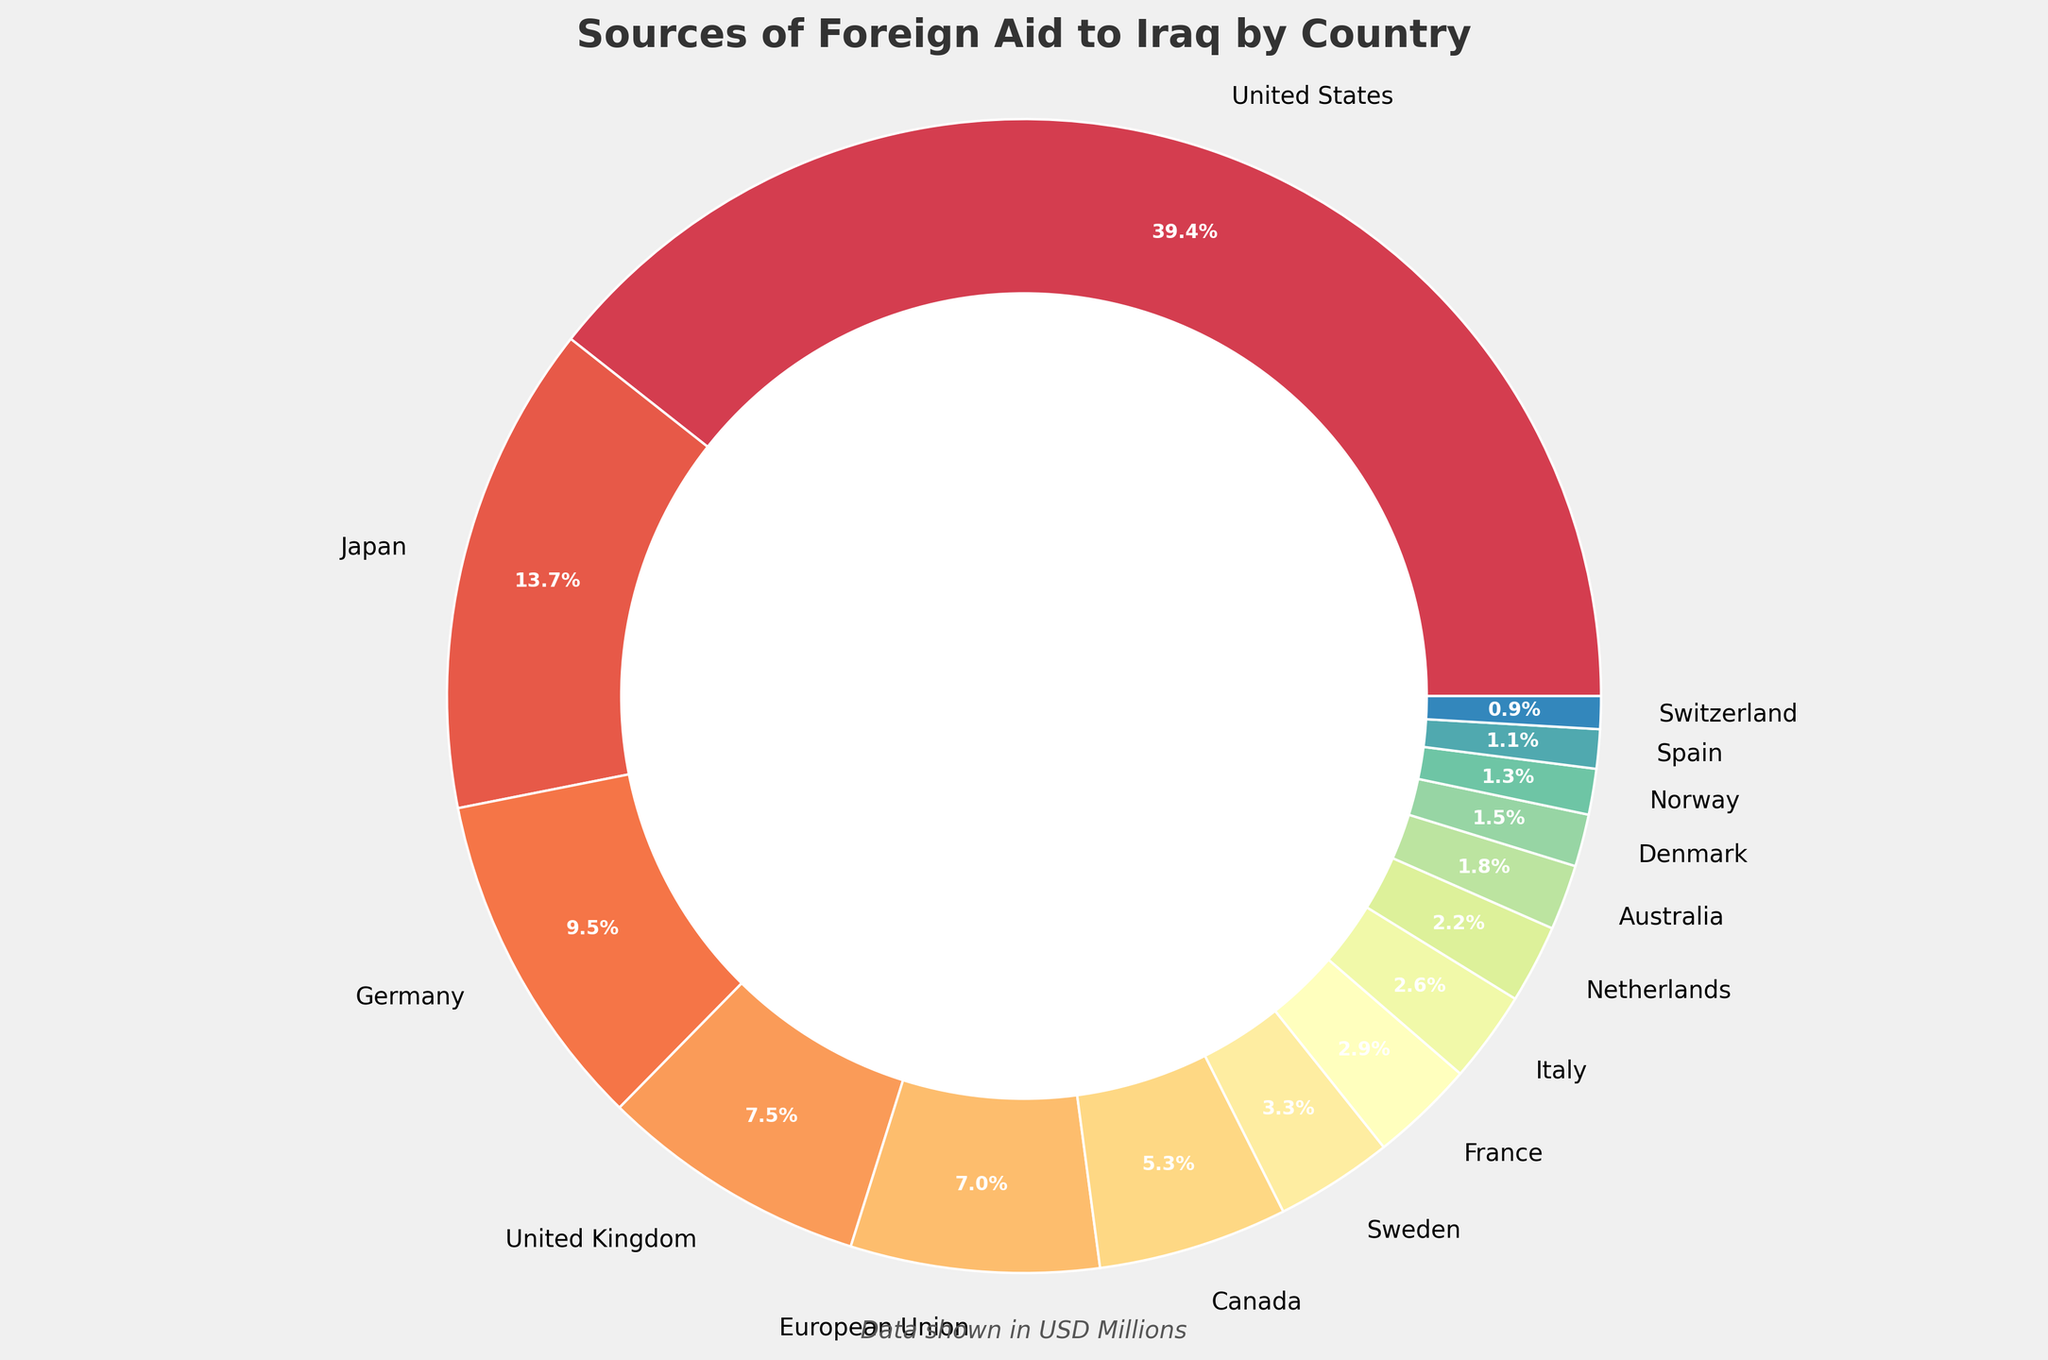what percentage of the total foreign aid comes from the United States? The United States' portion of the pie chart is labeled with its percentage. By referring to this label, we can directly see that the United States provides 44.3% of the total foreign aid.
Answer: 44.3% Which three countries contribute the most foreign aid? By looking at the pie chart, the countries with the largest sections are the United States, Japan, and Germany.
Answer: United States, Japan, Germany How much more aid does the United States provide compared to Germany? According to the pie chart, the United States provides $2,150 million, and Germany provides $520 million. The difference is $2,150 million - $520 million.
Answer: $1,630 million What is the combined percentage of foreign aid provided by the United States and Japan? The percentages for the United States and Japan can be found directly on the chart. The United States provides 44.3%, and Japan provides 15.5%. Adding these together gives 44.3% + 15.5%.
Answer: 59.8% Which country provides more aid: France or Italy? By comparing the sizes of the sections and their respective labels, it is clear that France provides $160 million, while Italy provides $140 million. France provides more.
Answer: France What is the smallest percentage of aid provided by a country, and which country provides it? The smallest section of the pie chart corresponds to Switzerland, which is indicated to provide 1.0% of the total aid.
Answer: 1.0%, Switzerland Is the aid amount provided by the European Union more than that provided by the United Kingdom? By comparing the aid amounts labeled on the chart, the European Union provides $380 million, while the United Kingdom provides $410 million. The European Union provides less.
Answer: No How much aid do the bottom five contributing countries provide in total? The bottom five countries by aid amount are Norway ($70 million), Spain ($60 million), and Switzerland ($50 million). Summing these gives $70 million + $60 million + $50 million.
Answer: $180 million Which two countries have a similar percentage of aid contribution and what are their percentages? By examining the chart, the United Kingdom and European Union have similar sections, representing 8.4% and 7.8% respectively.
Answer: United Kingdom (8.4%), European Union (7.8%) What is the visual representation used for the pie chart, and what is its purpose? The pie chart uses wedges of varying sizes to represent different countries' contributions to foreign aid. Each wedge's size is proportional to the aid amount, visually showcasing the comparative contributions.
Answer: Wedges proportional to aid amounts 